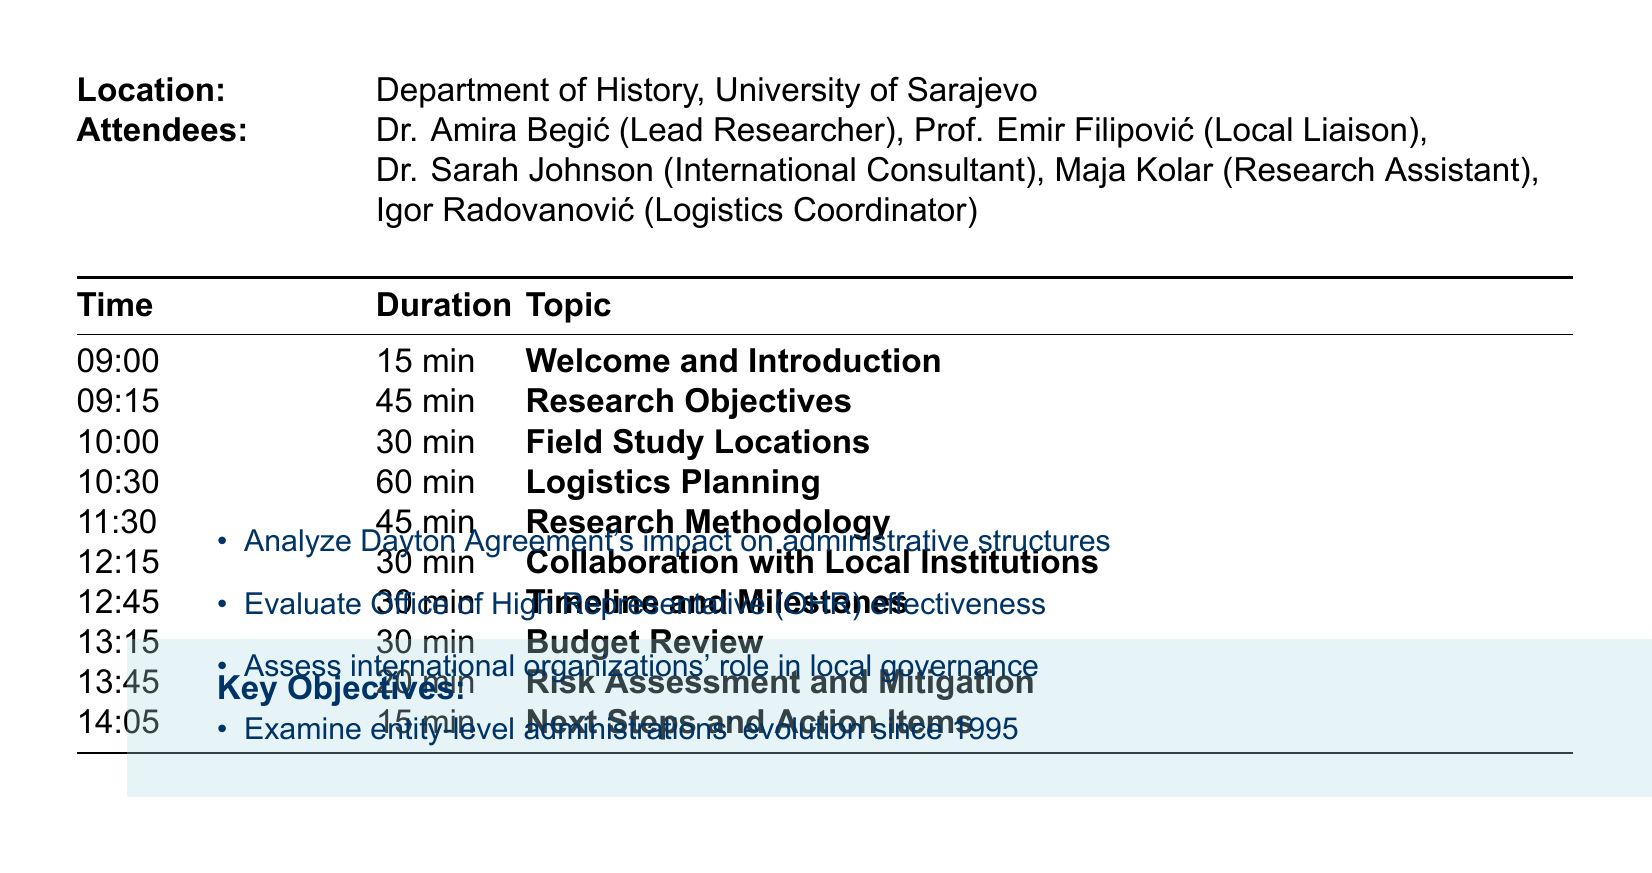What is the meeting title? The meeting title is stated at the beginning of the document, which is about the field study planning.
Answer: Field Study Planning: Post-Conflict Administrative Structures in Bosnia and Herzegovina Who is the lead researcher? The lead researcher is listed among the attendees in the document.
Answer: Dr. Amira Begić What is the date of the meeting? The date of the meeting is mentioned prominently within the document.
Answer: May 15, 2023 How long is the Logistics Planning segment? The durations for each agenda item are specified in the document.
Answer: 60 minutes What are the primary key objectives? The document lists key objectives in the context of the research to be conducted.
Answer: Analyze Dayton Agreement's impact on administrative structures Which location is included for field study besides Sarajevo? The document lists various locations for the field study.
Answer: Banja Luka When is the mid-study review scheduled? The timeline is outlined clearly in the document under the schedule section.
Answer: June 25, 2023 What is the duration of the field study? The document specifies the total duration for the planned field study.
Answer: June 1 - July 15, 2023 What role does Prof. Emir Filipović have in the meeting? The attendees' roles are listed, specifying their involvement.
Answer: Local Liaison 